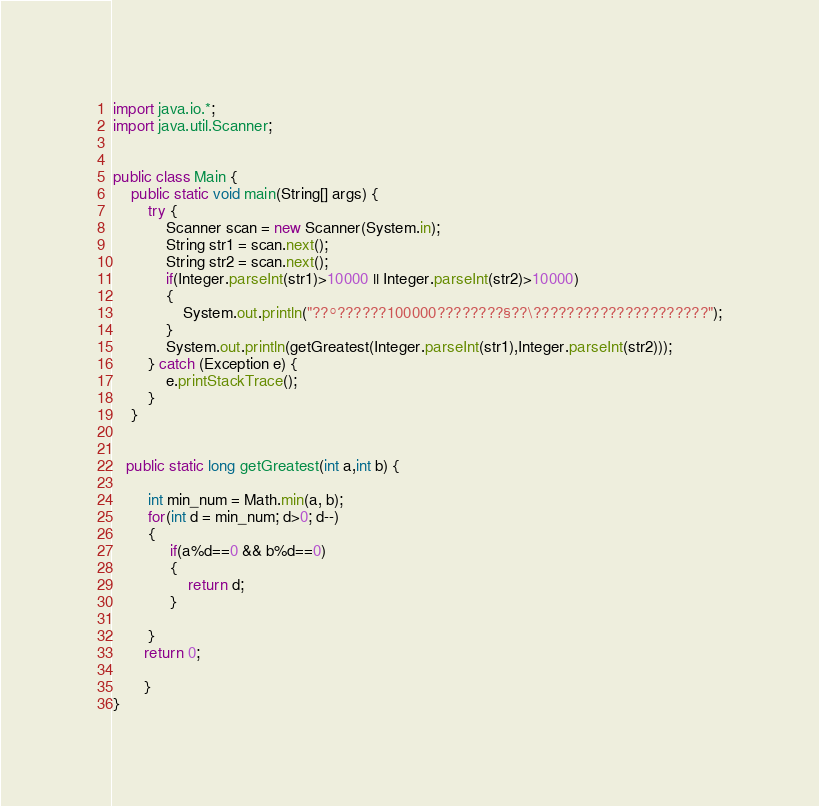Convert code to text. <code><loc_0><loc_0><loc_500><loc_500><_Java_>import java.io.*;
import java.util.Scanner;


public class Main {
    public static void main(String[] args) {
        try {
        	Scanner scan = new Scanner(System.in);
        	String str1 = scan.next();
        	String str2 = scan.next();
        	if(Integer.parseInt(str1)>10000 || Integer.parseInt(str2)>10000)
        	{
        		System.out.println("??°??????100000????????§??\?????????????????????");
        	}
        	System.out.println(getGreatest(Integer.parseInt(str1),Integer.parseInt(str2)));
        } catch (Exception e) {
            e.printStackTrace();
        }
    }

 
   public static long getGreatest(int a,int b) {
        
        int min_num = Math.min(a, b);
        for(int d = min_num; d>0; d--)
        {
             if(a%d==0 && b%d==0)
             {
            	 return d;
             }
   
        }
       return 0; 
        
       }
}</code> 